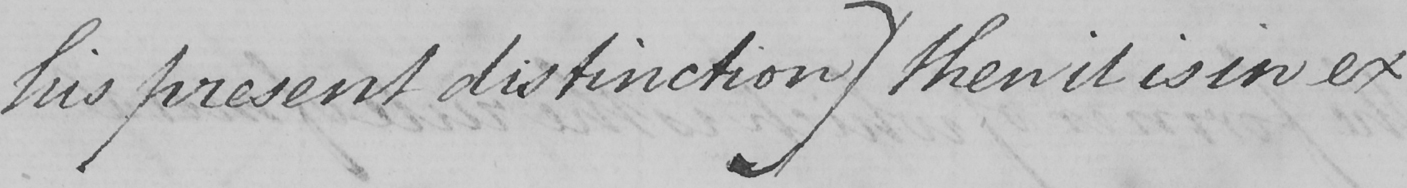Please provide the text content of this handwritten line. his present distinction )  then it is in ex 